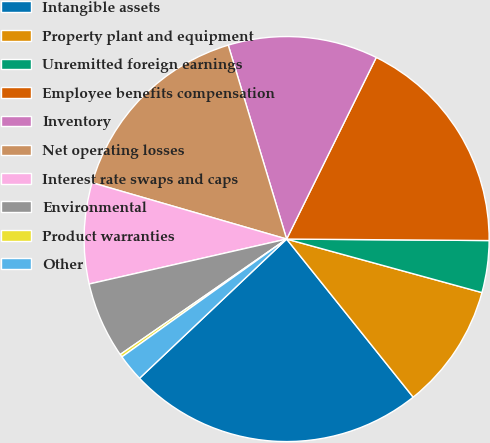<chart> <loc_0><loc_0><loc_500><loc_500><pie_chart><fcel>Intangible assets<fcel>Property plant and equipment<fcel>Unremitted foreign earnings<fcel>Employee benefits compensation<fcel>Inventory<fcel>Net operating losses<fcel>Interest rate swaps and caps<fcel>Environmental<fcel>Product warranties<fcel>Other<nl><fcel>23.68%<fcel>10.0%<fcel>4.14%<fcel>17.82%<fcel>11.95%<fcel>15.86%<fcel>8.05%<fcel>6.09%<fcel>0.23%<fcel>2.18%<nl></chart> 